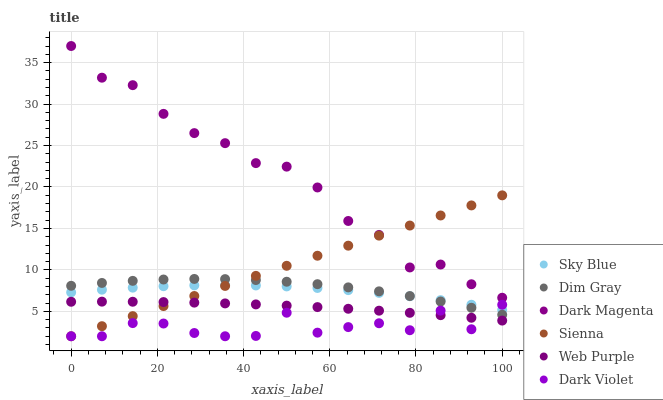Does Dark Violet have the minimum area under the curve?
Answer yes or no. Yes. Does Dark Magenta have the maximum area under the curve?
Answer yes or no. Yes. Does Dark Magenta have the minimum area under the curve?
Answer yes or no. No. Does Dark Violet have the maximum area under the curve?
Answer yes or no. No. Is Sienna the smoothest?
Answer yes or no. Yes. Is Dark Violet the roughest?
Answer yes or no. Yes. Is Dark Magenta the smoothest?
Answer yes or no. No. Is Dark Magenta the roughest?
Answer yes or no. No. Does Dark Violet have the lowest value?
Answer yes or no. Yes. Does Dark Magenta have the lowest value?
Answer yes or no. No. Does Dark Magenta have the highest value?
Answer yes or no. Yes. Does Dark Violet have the highest value?
Answer yes or no. No. Is Dark Violet less than Dark Magenta?
Answer yes or no. Yes. Is Dark Magenta greater than Web Purple?
Answer yes or no. Yes. Does Dark Violet intersect Web Purple?
Answer yes or no. Yes. Is Dark Violet less than Web Purple?
Answer yes or no. No. Is Dark Violet greater than Web Purple?
Answer yes or no. No. Does Dark Violet intersect Dark Magenta?
Answer yes or no. No. 